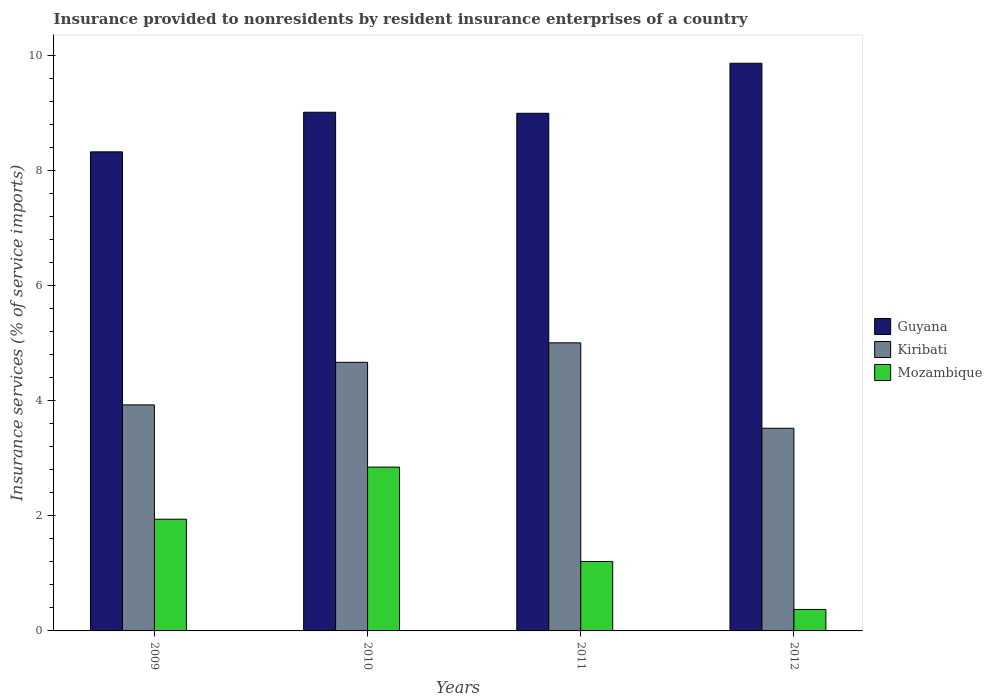How many different coloured bars are there?
Ensure brevity in your answer.  3. How many groups of bars are there?
Provide a short and direct response. 4. Are the number of bars per tick equal to the number of legend labels?
Give a very brief answer. Yes. Are the number of bars on each tick of the X-axis equal?
Offer a terse response. Yes. How many bars are there on the 2nd tick from the left?
Make the answer very short. 3. What is the label of the 4th group of bars from the left?
Make the answer very short. 2012. What is the insurance provided to nonresidents in Mozambique in 2012?
Your answer should be compact. 0.37. Across all years, what is the maximum insurance provided to nonresidents in Kiribati?
Ensure brevity in your answer.  5.01. Across all years, what is the minimum insurance provided to nonresidents in Kiribati?
Provide a short and direct response. 3.52. What is the total insurance provided to nonresidents in Kiribati in the graph?
Offer a very short reply. 17.13. What is the difference between the insurance provided to nonresidents in Kiribati in 2009 and that in 2010?
Keep it short and to the point. -0.74. What is the difference between the insurance provided to nonresidents in Kiribati in 2011 and the insurance provided to nonresidents in Mozambique in 2009?
Your answer should be very brief. 3.07. What is the average insurance provided to nonresidents in Kiribati per year?
Offer a terse response. 4.28. In the year 2012, what is the difference between the insurance provided to nonresidents in Guyana and insurance provided to nonresidents in Mozambique?
Offer a terse response. 9.5. What is the ratio of the insurance provided to nonresidents in Guyana in 2010 to that in 2011?
Your response must be concise. 1. Is the insurance provided to nonresidents in Guyana in 2011 less than that in 2012?
Provide a succinct answer. Yes. Is the difference between the insurance provided to nonresidents in Guyana in 2009 and 2011 greater than the difference between the insurance provided to nonresidents in Mozambique in 2009 and 2011?
Offer a terse response. No. What is the difference between the highest and the second highest insurance provided to nonresidents in Guyana?
Your response must be concise. 0.85. What is the difference between the highest and the lowest insurance provided to nonresidents in Guyana?
Give a very brief answer. 1.54. Is the sum of the insurance provided to nonresidents in Kiribati in 2009 and 2011 greater than the maximum insurance provided to nonresidents in Mozambique across all years?
Your answer should be compact. Yes. What does the 1st bar from the left in 2012 represents?
Your response must be concise. Guyana. What does the 2nd bar from the right in 2009 represents?
Make the answer very short. Kiribati. Is it the case that in every year, the sum of the insurance provided to nonresidents in Mozambique and insurance provided to nonresidents in Kiribati is greater than the insurance provided to nonresidents in Guyana?
Keep it short and to the point. No. Are all the bars in the graph horizontal?
Offer a terse response. No. What is the difference between two consecutive major ticks on the Y-axis?
Give a very brief answer. 2. Does the graph contain any zero values?
Your response must be concise. No. Where does the legend appear in the graph?
Your answer should be very brief. Center right. What is the title of the graph?
Keep it short and to the point. Insurance provided to nonresidents by resident insurance enterprises of a country. What is the label or title of the X-axis?
Make the answer very short. Years. What is the label or title of the Y-axis?
Provide a succinct answer. Insurance services (% of service imports). What is the Insurance services (% of service imports) in Guyana in 2009?
Offer a very short reply. 8.33. What is the Insurance services (% of service imports) in Kiribati in 2009?
Provide a short and direct response. 3.93. What is the Insurance services (% of service imports) of Mozambique in 2009?
Keep it short and to the point. 1.94. What is the Insurance services (% of service imports) in Guyana in 2010?
Give a very brief answer. 9.02. What is the Insurance services (% of service imports) of Kiribati in 2010?
Your answer should be very brief. 4.67. What is the Insurance services (% of service imports) in Mozambique in 2010?
Your answer should be compact. 2.85. What is the Insurance services (% of service imports) of Guyana in 2011?
Offer a very short reply. 9. What is the Insurance services (% of service imports) in Kiribati in 2011?
Give a very brief answer. 5.01. What is the Insurance services (% of service imports) in Mozambique in 2011?
Keep it short and to the point. 1.21. What is the Insurance services (% of service imports) of Guyana in 2012?
Offer a very short reply. 9.87. What is the Insurance services (% of service imports) in Kiribati in 2012?
Your answer should be compact. 3.52. What is the Insurance services (% of service imports) in Mozambique in 2012?
Your answer should be very brief. 0.37. Across all years, what is the maximum Insurance services (% of service imports) of Guyana?
Ensure brevity in your answer.  9.87. Across all years, what is the maximum Insurance services (% of service imports) of Kiribati?
Your answer should be compact. 5.01. Across all years, what is the maximum Insurance services (% of service imports) of Mozambique?
Give a very brief answer. 2.85. Across all years, what is the minimum Insurance services (% of service imports) of Guyana?
Offer a very short reply. 8.33. Across all years, what is the minimum Insurance services (% of service imports) of Kiribati?
Give a very brief answer. 3.52. Across all years, what is the minimum Insurance services (% of service imports) in Mozambique?
Provide a short and direct response. 0.37. What is the total Insurance services (% of service imports) of Guyana in the graph?
Offer a terse response. 36.22. What is the total Insurance services (% of service imports) of Kiribati in the graph?
Provide a short and direct response. 17.13. What is the total Insurance services (% of service imports) in Mozambique in the graph?
Offer a terse response. 6.37. What is the difference between the Insurance services (% of service imports) in Guyana in 2009 and that in 2010?
Offer a terse response. -0.69. What is the difference between the Insurance services (% of service imports) in Kiribati in 2009 and that in 2010?
Your response must be concise. -0.74. What is the difference between the Insurance services (% of service imports) in Mozambique in 2009 and that in 2010?
Make the answer very short. -0.91. What is the difference between the Insurance services (% of service imports) in Guyana in 2009 and that in 2011?
Make the answer very short. -0.67. What is the difference between the Insurance services (% of service imports) of Kiribati in 2009 and that in 2011?
Give a very brief answer. -1.08. What is the difference between the Insurance services (% of service imports) of Mozambique in 2009 and that in 2011?
Offer a very short reply. 0.74. What is the difference between the Insurance services (% of service imports) in Guyana in 2009 and that in 2012?
Your answer should be compact. -1.54. What is the difference between the Insurance services (% of service imports) of Kiribati in 2009 and that in 2012?
Your answer should be compact. 0.41. What is the difference between the Insurance services (% of service imports) in Mozambique in 2009 and that in 2012?
Your answer should be very brief. 1.57. What is the difference between the Insurance services (% of service imports) in Guyana in 2010 and that in 2011?
Give a very brief answer. 0.02. What is the difference between the Insurance services (% of service imports) in Kiribati in 2010 and that in 2011?
Ensure brevity in your answer.  -0.34. What is the difference between the Insurance services (% of service imports) in Mozambique in 2010 and that in 2011?
Your answer should be compact. 1.64. What is the difference between the Insurance services (% of service imports) of Guyana in 2010 and that in 2012?
Offer a terse response. -0.85. What is the difference between the Insurance services (% of service imports) in Kiribati in 2010 and that in 2012?
Provide a succinct answer. 1.15. What is the difference between the Insurance services (% of service imports) of Mozambique in 2010 and that in 2012?
Offer a very short reply. 2.47. What is the difference between the Insurance services (% of service imports) in Guyana in 2011 and that in 2012?
Give a very brief answer. -0.87. What is the difference between the Insurance services (% of service imports) of Kiribati in 2011 and that in 2012?
Your answer should be very brief. 1.48. What is the difference between the Insurance services (% of service imports) in Mozambique in 2011 and that in 2012?
Ensure brevity in your answer.  0.83. What is the difference between the Insurance services (% of service imports) of Guyana in 2009 and the Insurance services (% of service imports) of Kiribati in 2010?
Provide a succinct answer. 3.66. What is the difference between the Insurance services (% of service imports) of Guyana in 2009 and the Insurance services (% of service imports) of Mozambique in 2010?
Ensure brevity in your answer.  5.48. What is the difference between the Insurance services (% of service imports) in Kiribati in 2009 and the Insurance services (% of service imports) in Mozambique in 2010?
Provide a succinct answer. 1.08. What is the difference between the Insurance services (% of service imports) of Guyana in 2009 and the Insurance services (% of service imports) of Kiribati in 2011?
Provide a succinct answer. 3.32. What is the difference between the Insurance services (% of service imports) in Guyana in 2009 and the Insurance services (% of service imports) in Mozambique in 2011?
Provide a short and direct response. 7.12. What is the difference between the Insurance services (% of service imports) in Kiribati in 2009 and the Insurance services (% of service imports) in Mozambique in 2011?
Your answer should be very brief. 2.72. What is the difference between the Insurance services (% of service imports) of Guyana in 2009 and the Insurance services (% of service imports) of Kiribati in 2012?
Ensure brevity in your answer.  4.81. What is the difference between the Insurance services (% of service imports) in Guyana in 2009 and the Insurance services (% of service imports) in Mozambique in 2012?
Your answer should be compact. 7.96. What is the difference between the Insurance services (% of service imports) of Kiribati in 2009 and the Insurance services (% of service imports) of Mozambique in 2012?
Your answer should be compact. 3.56. What is the difference between the Insurance services (% of service imports) in Guyana in 2010 and the Insurance services (% of service imports) in Kiribati in 2011?
Offer a terse response. 4.01. What is the difference between the Insurance services (% of service imports) of Guyana in 2010 and the Insurance services (% of service imports) of Mozambique in 2011?
Ensure brevity in your answer.  7.81. What is the difference between the Insurance services (% of service imports) of Kiribati in 2010 and the Insurance services (% of service imports) of Mozambique in 2011?
Give a very brief answer. 3.46. What is the difference between the Insurance services (% of service imports) of Guyana in 2010 and the Insurance services (% of service imports) of Kiribati in 2012?
Keep it short and to the point. 5.49. What is the difference between the Insurance services (% of service imports) in Guyana in 2010 and the Insurance services (% of service imports) in Mozambique in 2012?
Your answer should be compact. 8.64. What is the difference between the Insurance services (% of service imports) in Kiribati in 2010 and the Insurance services (% of service imports) in Mozambique in 2012?
Your answer should be compact. 4.3. What is the difference between the Insurance services (% of service imports) in Guyana in 2011 and the Insurance services (% of service imports) in Kiribati in 2012?
Your answer should be very brief. 5.48. What is the difference between the Insurance services (% of service imports) in Guyana in 2011 and the Insurance services (% of service imports) in Mozambique in 2012?
Give a very brief answer. 8.63. What is the difference between the Insurance services (% of service imports) in Kiribati in 2011 and the Insurance services (% of service imports) in Mozambique in 2012?
Ensure brevity in your answer.  4.64. What is the average Insurance services (% of service imports) in Guyana per year?
Make the answer very short. 9.05. What is the average Insurance services (% of service imports) in Kiribati per year?
Give a very brief answer. 4.28. What is the average Insurance services (% of service imports) of Mozambique per year?
Keep it short and to the point. 1.59. In the year 2009, what is the difference between the Insurance services (% of service imports) in Guyana and Insurance services (% of service imports) in Kiribati?
Offer a terse response. 4.4. In the year 2009, what is the difference between the Insurance services (% of service imports) in Guyana and Insurance services (% of service imports) in Mozambique?
Your response must be concise. 6.39. In the year 2009, what is the difference between the Insurance services (% of service imports) of Kiribati and Insurance services (% of service imports) of Mozambique?
Your answer should be very brief. 1.99. In the year 2010, what is the difference between the Insurance services (% of service imports) of Guyana and Insurance services (% of service imports) of Kiribati?
Provide a succinct answer. 4.35. In the year 2010, what is the difference between the Insurance services (% of service imports) in Guyana and Insurance services (% of service imports) in Mozambique?
Provide a short and direct response. 6.17. In the year 2010, what is the difference between the Insurance services (% of service imports) of Kiribati and Insurance services (% of service imports) of Mozambique?
Offer a very short reply. 1.82. In the year 2011, what is the difference between the Insurance services (% of service imports) in Guyana and Insurance services (% of service imports) in Kiribati?
Provide a succinct answer. 3.99. In the year 2011, what is the difference between the Insurance services (% of service imports) of Guyana and Insurance services (% of service imports) of Mozambique?
Your answer should be very brief. 7.79. In the year 2011, what is the difference between the Insurance services (% of service imports) of Kiribati and Insurance services (% of service imports) of Mozambique?
Provide a succinct answer. 3.8. In the year 2012, what is the difference between the Insurance services (% of service imports) of Guyana and Insurance services (% of service imports) of Kiribati?
Make the answer very short. 6.35. In the year 2012, what is the difference between the Insurance services (% of service imports) of Guyana and Insurance services (% of service imports) of Mozambique?
Offer a terse response. 9.5. In the year 2012, what is the difference between the Insurance services (% of service imports) in Kiribati and Insurance services (% of service imports) in Mozambique?
Your response must be concise. 3.15. What is the ratio of the Insurance services (% of service imports) in Guyana in 2009 to that in 2010?
Provide a short and direct response. 0.92. What is the ratio of the Insurance services (% of service imports) of Kiribati in 2009 to that in 2010?
Give a very brief answer. 0.84. What is the ratio of the Insurance services (% of service imports) in Mozambique in 2009 to that in 2010?
Provide a short and direct response. 0.68. What is the ratio of the Insurance services (% of service imports) in Guyana in 2009 to that in 2011?
Ensure brevity in your answer.  0.93. What is the ratio of the Insurance services (% of service imports) in Kiribati in 2009 to that in 2011?
Ensure brevity in your answer.  0.78. What is the ratio of the Insurance services (% of service imports) in Mozambique in 2009 to that in 2011?
Provide a short and direct response. 1.61. What is the ratio of the Insurance services (% of service imports) of Guyana in 2009 to that in 2012?
Keep it short and to the point. 0.84. What is the ratio of the Insurance services (% of service imports) of Kiribati in 2009 to that in 2012?
Offer a very short reply. 1.12. What is the ratio of the Insurance services (% of service imports) of Mozambique in 2009 to that in 2012?
Make the answer very short. 5.2. What is the ratio of the Insurance services (% of service imports) of Kiribati in 2010 to that in 2011?
Keep it short and to the point. 0.93. What is the ratio of the Insurance services (% of service imports) in Mozambique in 2010 to that in 2011?
Give a very brief answer. 2.36. What is the ratio of the Insurance services (% of service imports) of Guyana in 2010 to that in 2012?
Provide a short and direct response. 0.91. What is the ratio of the Insurance services (% of service imports) of Kiribati in 2010 to that in 2012?
Give a very brief answer. 1.33. What is the ratio of the Insurance services (% of service imports) in Mozambique in 2010 to that in 2012?
Ensure brevity in your answer.  7.63. What is the ratio of the Insurance services (% of service imports) of Guyana in 2011 to that in 2012?
Offer a terse response. 0.91. What is the ratio of the Insurance services (% of service imports) in Kiribati in 2011 to that in 2012?
Keep it short and to the point. 1.42. What is the ratio of the Insurance services (% of service imports) in Mozambique in 2011 to that in 2012?
Keep it short and to the point. 3.23. What is the difference between the highest and the second highest Insurance services (% of service imports) in Guyana?
Make the answer very short. 0.85. What is the difference between the highest and the second highest Insurance services (% of service imports) of Kiribati?
Your answer should be very brief. 0.34. What is the difference between the highest and the second highest Insurance services (% of service imports) of Mozambique?
Your response must be concise. 0.91. What is the difference between the highest and the lowest Insurance services (% of service imports) in Guyana?
Your response must be concise. 1.54. What is the difference between the highest and the lowest Insurance services (% of service imports) in Kiribati?
Provide a short and direct response. 1.48. What is the difference between the highest and the lowest Insurance services (% of service imports) of Mozambique?
Make the answer very short. 2.47. 